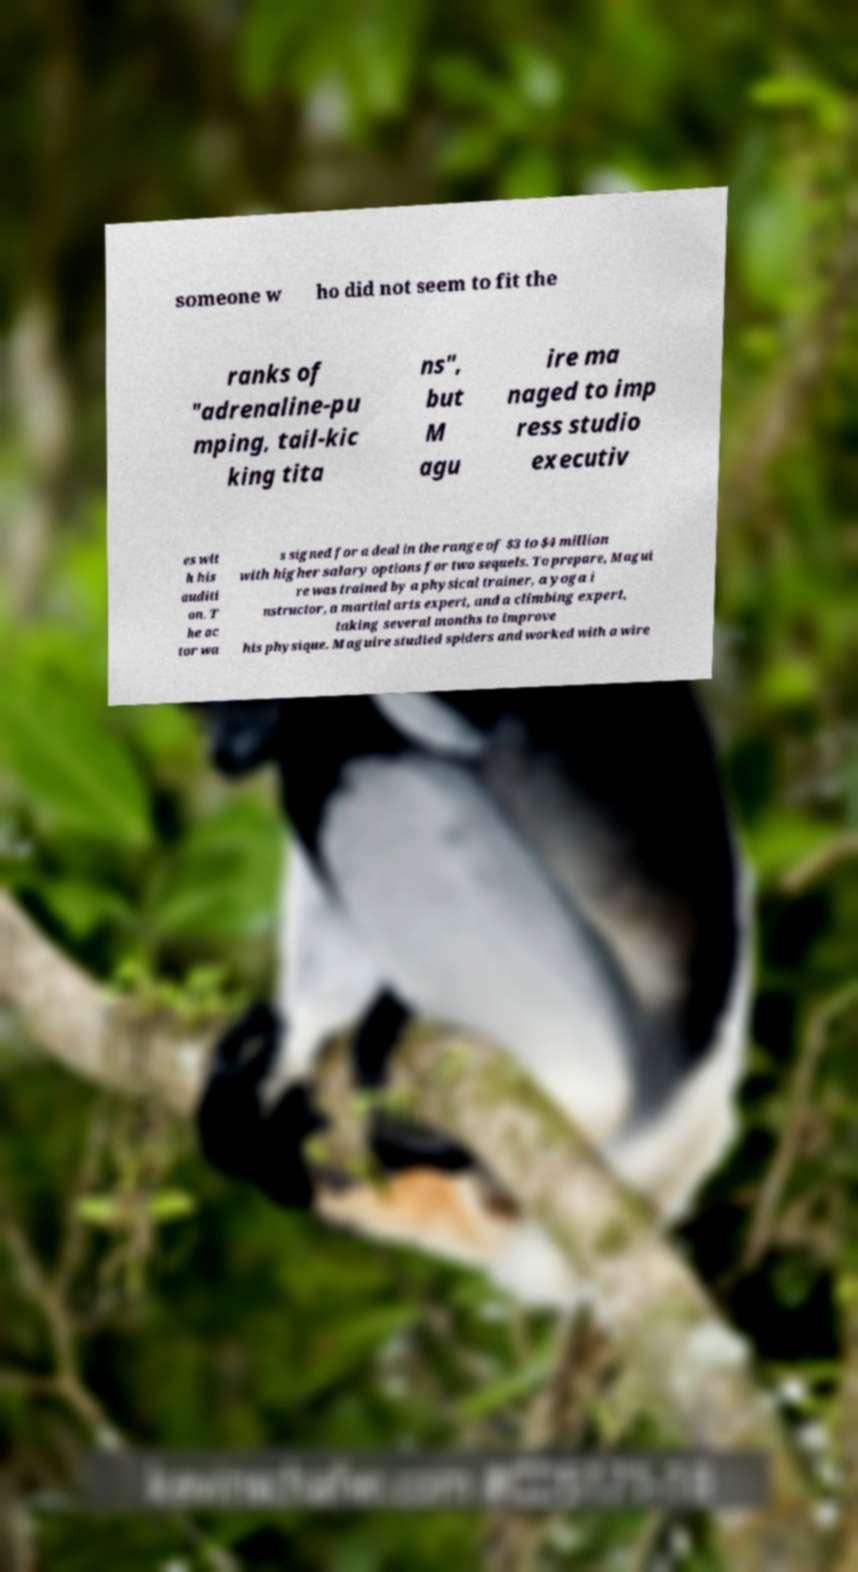For documentation purposes, I need the text within this image transcribed. Could you provide that? someone w ho did not seem to fit the ranks of "adrenaline-pu mping, tail-kic king tita ns", but M agu ire ma naged to imp ress studio executiv es wit h his auditi on. T he ac tor wa s signed for a deal in the range of $3 to $4 million with higher salary options for two sequels. To prepare, Magui re was trained by a physical trainer, a yoga i nstructor, a martial arts expert, and a climbing expert, taking several months to improve his physique. Maguire studied spiders and worked with a wire 